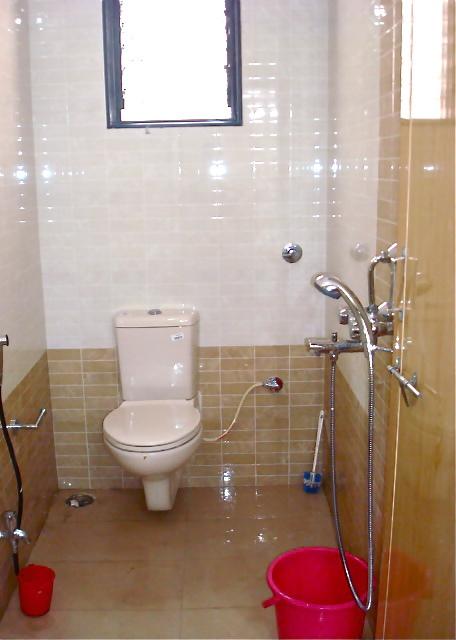Is the room lit by sunlight?
Write a very short answer. Yes. Where is the flush button?
Keep it brief. Wall. What color is the largest bucket?
Quick response, please. Red. 